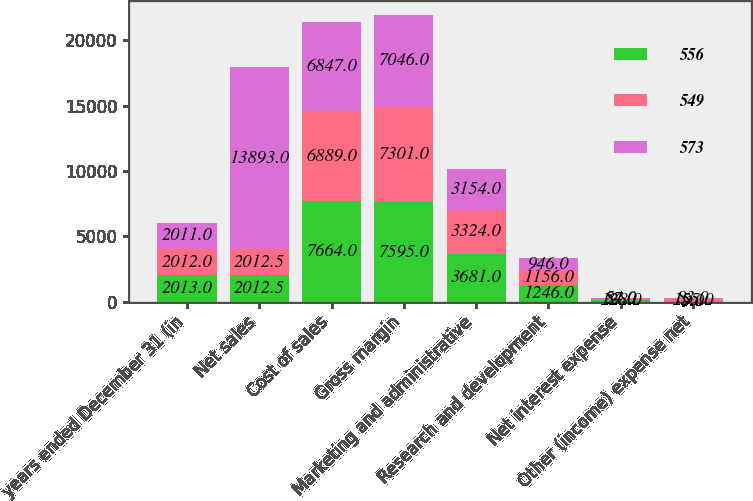<chart> <loc_0><loc_0><loc_500><loc_500><stacked_bar_chart><ecel><fcel>years ended December 31 (in<fcel>Net sales<fcel>Cost of sales<fcel>Gross margin<fcel>Marketing and administrative<fcel>Research and development<fcel>Net interest expense<fcel>Other (income) expense net<nl><fcel>556<fcel>2013<fcel>2012.5<fcel>7664<fcel>7595<fcel>3681<fcel>1246<fcel>128<fcel>9<nl><fcel>549<fcel>2012<fcel>2012.5<fcel>6889<fcel>7301<fcel>3324<fcel>1156<fcel>87<fcel>155<nl><fcel>573<fcel>2011<fcel>13893<fcel>6847<fcel>7046<fcel>3154<fcel>946<fcel>54<fcel>83<nl></chart> 